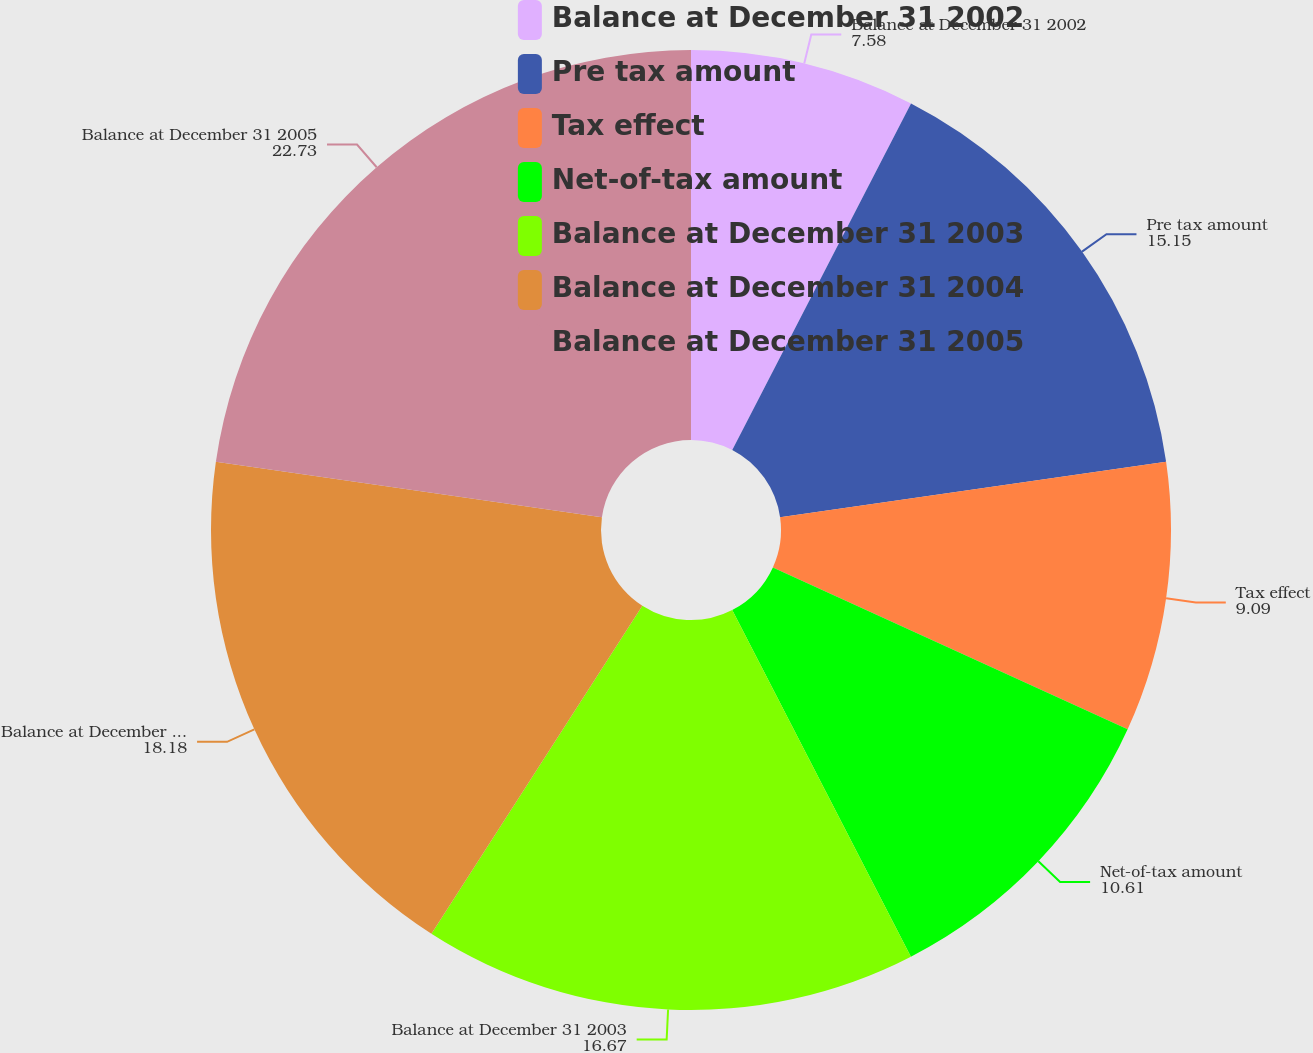<chart> <loc_0><loc_0><loc_500><loc_500><pie_chart><fcel>Balance at December 31 2002<fcel>Pre tax amount<fcel>Tax effect<fcel>Net-of-tax amount<fcel>Balance at December 31 2003<fcel>Balance at December 31 2004<fcel>Balance at December 31 2005<nl><fcel>7.58%<fcel>15.15%<fcel>9.09%<fcel>10.61%<fcel>16.67%<fcel>18.18%<fcel>22.73%<nl></chart> 